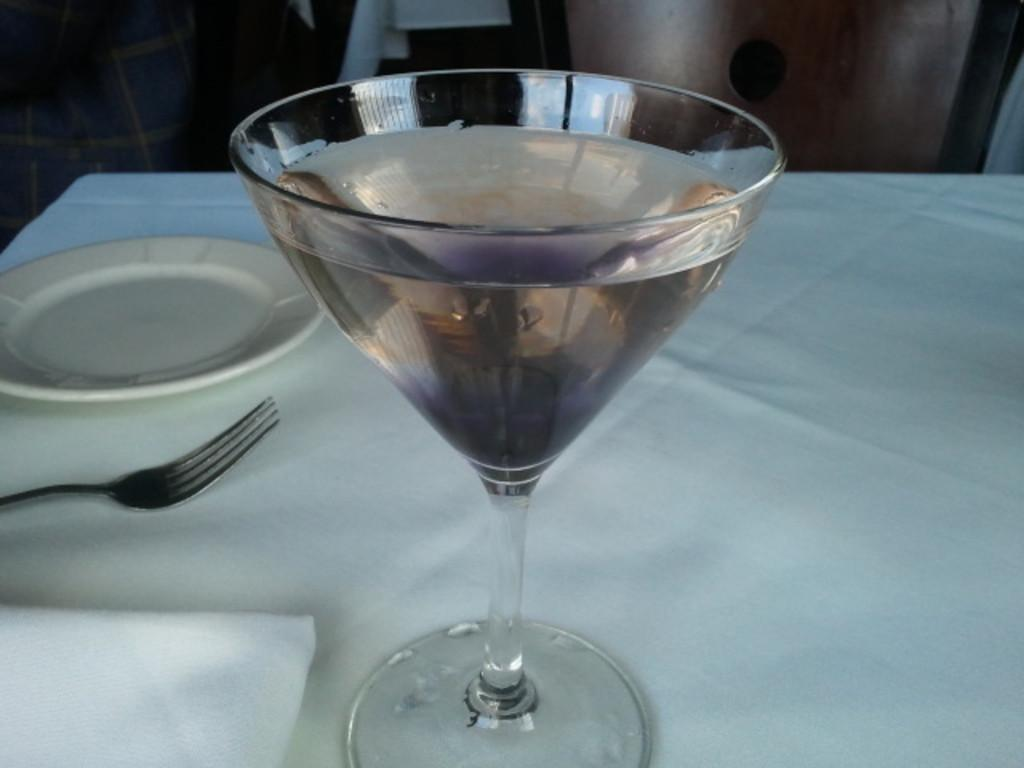What piece of furniture is present in the image? There is a table in the image. What is placed on the table? There is a glass tumbler filled with beverage, a fork, a paper napkin, and a serving plate on the table. What might be used for drinking in the image? The glass tumbler filled with beverage can be used for drinking. What might be used for cleaning or wiping in the image? The paper napkin can be used for cleaning or wiping. Can you see the toe of someone in the image? There is no toe visible in the image. What type of drum is being played in the image? There is no drum present in the image. 